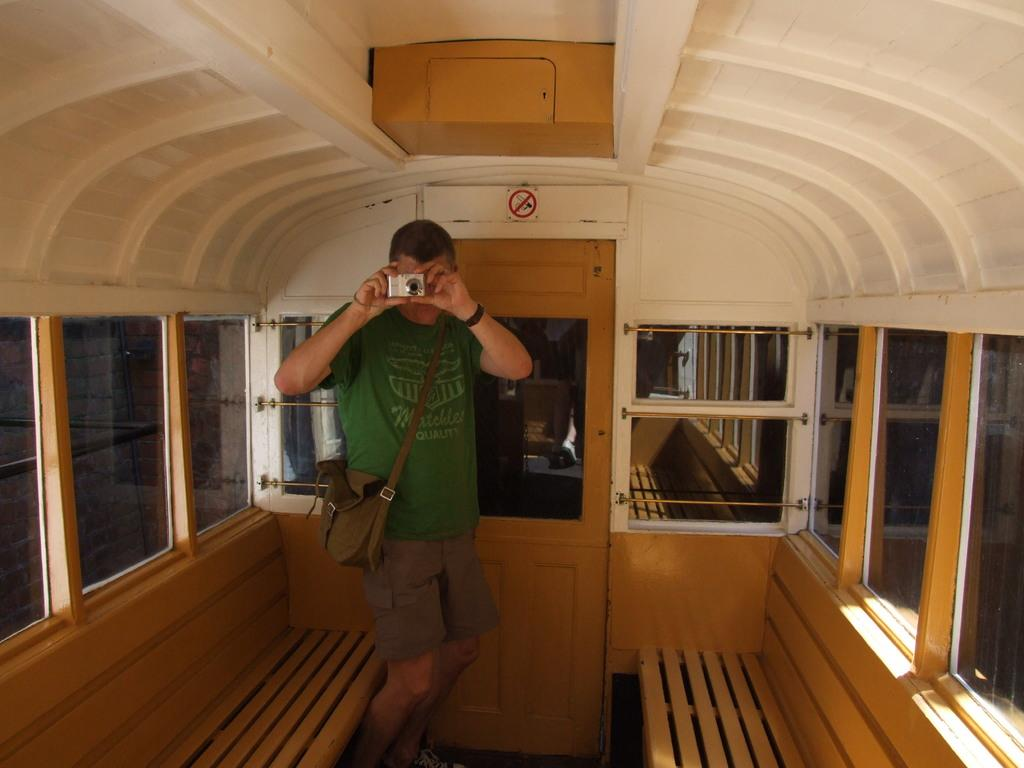Who is present in the image? There is a man in the image. What is the man holding in his hands? The man is holding a camera in his hands. What is the man wearing on his body? The man is wearing a bag. What type of seating can be seen in the image? There are benches in the image. What is the flat, rectangular object in the image? There is a board in the image. What is the opening that can be used to enter or exit a room? There is a door in the image. What type of eyewear is present in the image? There are glasses in the image. What type of grain is being harvested in the image? There is no grain or harvesting activity present in the image. Can you see the man's sister in the image? The provided facts do not mention a sister, so it cannot be determined if the man has a sister in the image. 